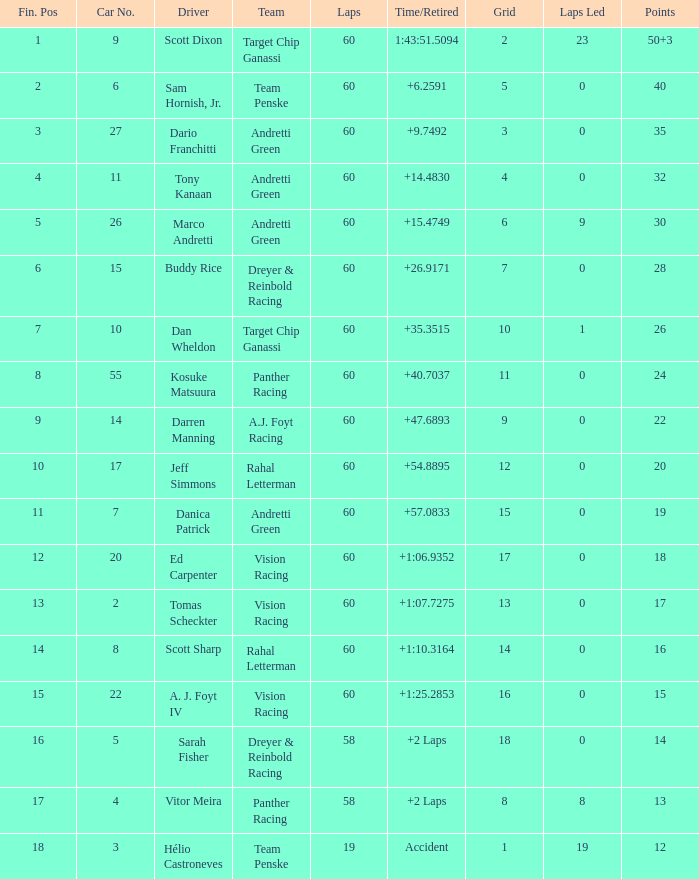What is the motivation for having 13 points? Vitor Meira. 